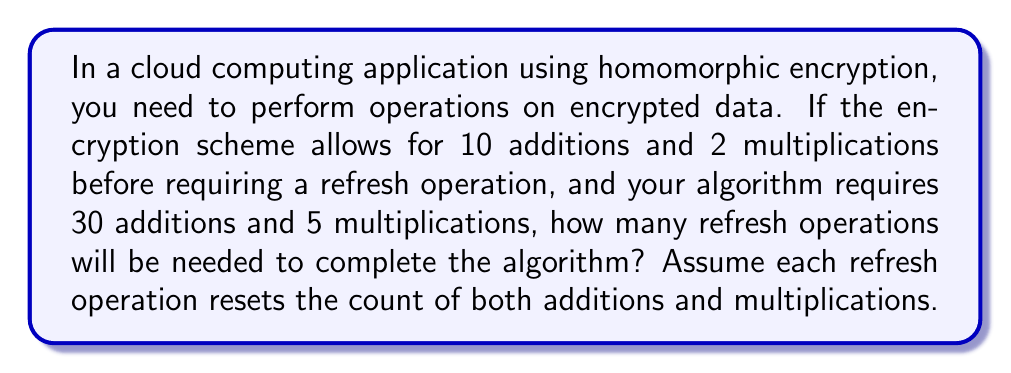Provide a solution to this math problem. Let's approach this step-by-step:

1) First, let's define our variables:
   $a$ = number of additions allowed before refresh
   $m$ = number of multiplications allowed before refresh
   $A$ = total number of additions required
   $M$ = total number of multiplications required

2) We're given:
   $a = 10$, $m = 2$, $A = 30$, $M = 5$

3) We need to find how many "sets" of operations we can perform before needing a refresh. This will be limited by whichever operation (addition or multiplication) reaches its limit first.

4) For additions:
   $\text{Sets of additions} = \left\lceil\frac{A}{a}\right\rceil = \left\lceil\frac{30}{10}\right\rceil = 3$

5) For multiplications:
   $\text{Sets of multiplications} = \left\lceil\frac{M}{m}\right\rceil = \left\lceil\frac{5}{2}\right\rceil = 3$

6) Both additions and multiplications require 3 sets. This means we will need to perform 2 refresh operations:
   - First set of operations
   - Refresh
   - Second set of operations
   - Refresh
   - Third set of operations

7) Therefore, the number of refresh operations needed is 2.
Answer: 2 